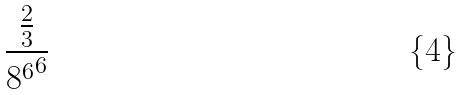Convert formula to latex. <formula><loc_0><loc_0><loc_500><loc_500>\frac { \frac { 2 } { 3 } } { { 8 ^ { 6 } } ^ { 6 } }</formula> 